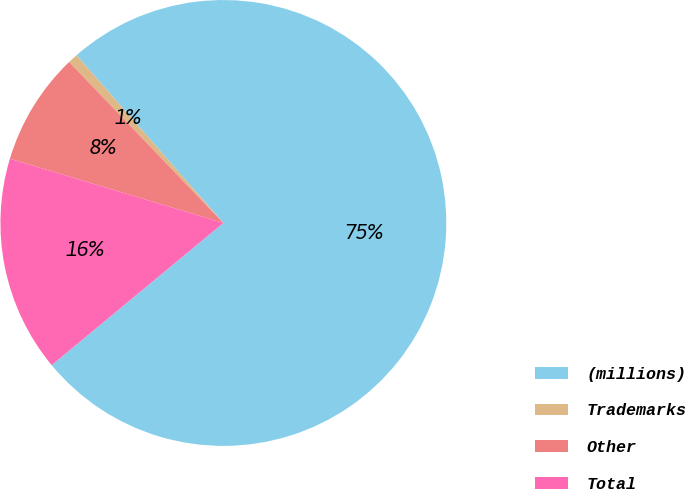Convert chart to OTSL. <chart><loc_0><loc_0><loc_500><loc_500><pie_chart><fcel>(millions)<fcel>Trademarks<fcel>Other<fcel>Total<nl><fcel>75.44%<fcel>0.71%<fcel>8.19%<fcel>15.66%<nl></chart> 